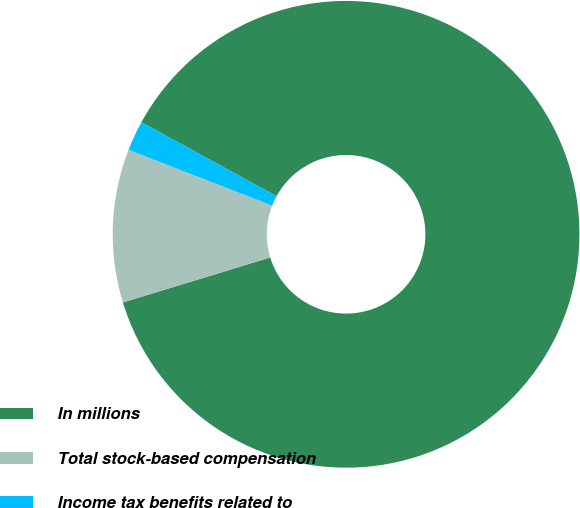Convert chart. <chart><loc_0><loc_0><loc_500><loc_500><pie_chart><fcel>In millions<fcel>Total stock-based compensation<fcel>Income tax benefits related to<nl><fcel>87.31%<fcel>10.61%<fcel>2.08%<nl></chart> 